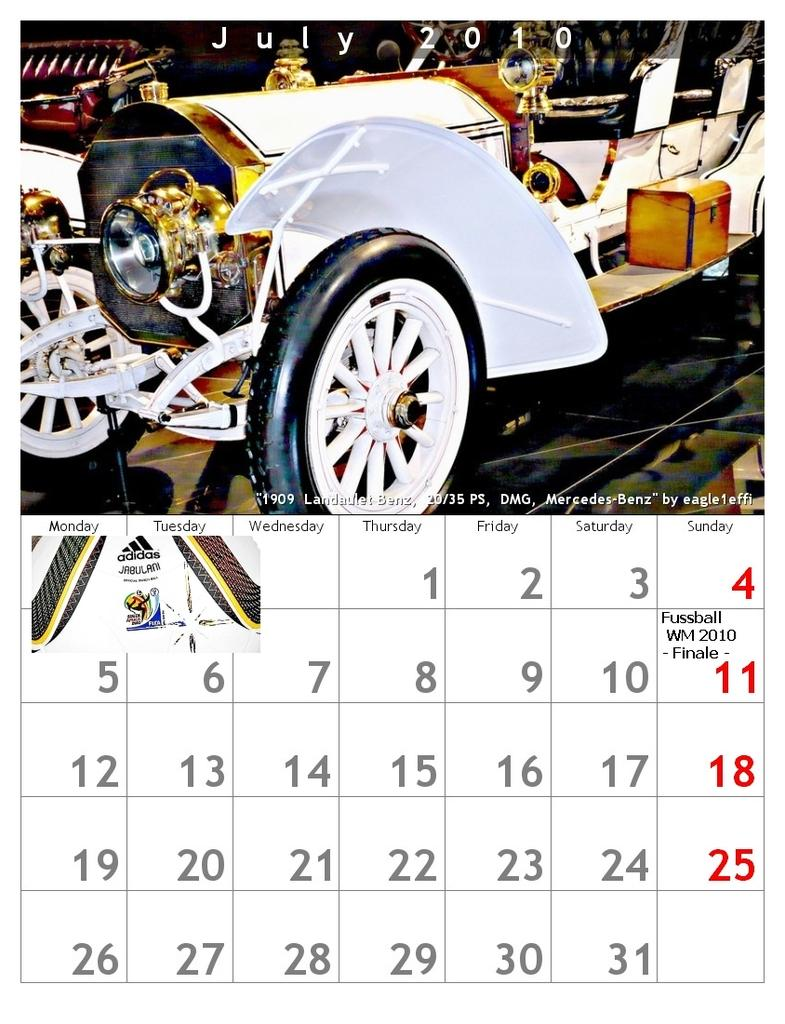What type of visual might the image be? The image might be a poster. What can be found at the bottom of the image? There is a calendar at the bottom of the image. What is located at the top of the image? There is a vehicle at the top of the image. What is present in the image that conveys information or messages? There is text in the image. What else can be seen in the image besides the calendar and vehicle? There are objects in the image. What thrilling activity is taking place in the image? There is no indication of any thrilling activity in the image. --- Facts: 1. There is a person in the image. 2. The person is wearing a hat. 3. The person is holding a book. 4. The background of the image is a park. 5. There are trees in the background. Absurd Topics: elephant, ocean, parrot Conversation: Who or what is present in the image? There is a person in the image. What is the person wearing in the image? The person is wearing a hat. What is the person holding in the image? The person is holding a book. What can be seen in the background of the image? The background of the image is a park. What type of vegetation is visible in the background of the image? There are trees in the background. Reasoning: Let's think step by step in order to produce the conversation. We start by identifying the main subject of the image, which is the person. Next, we describe specific details about the person, such as the hat and the book they are holding. Then, we observe the background of the image, noting that it is a park with trees. Finally, we describe the type of vegetation visible in the background of the image, which are trees. Absurd Question/Answer: Can you see any elephants, parrots, or ocean in the image? No, there are no elephants, parrots, or ocean visible in the image. The image features a person wearing a hat, holding a book, and is set in a park with trees in the background. 